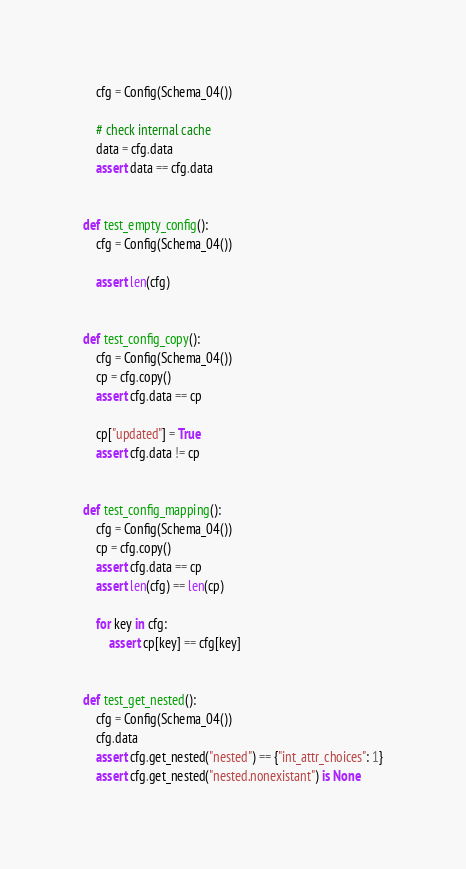<code> <loc_0><loc_0><loc_500><loc_500><_Python_>    cfg = Config(Schema_04())

    # check internal cache
    data = cfg.data
    assert data == cfg.data


def test_empty_config():
    cfg = Config(Schema_04())

    assert len(cfg)


def test_config_copy():
    cfg = Config(Schema_04())
    cp = cfg.copy()
    assert cfg.data == cp

    cp["updated"] = True
    assert cfg.data != cp


def test_config_mapping():
    cfg = Config(Schema_04())
    cp = cfg.copy()
    assert cfg.data == cp
    assert len(cfg) == len(cp)

    for key in cfg:
        assert cp[key] == cfg[key]


def test_get_nested():
    cfg = Config(Schema_04())
    cfg.data
    assert cfg.get_nested("nested") == {"int_attr_choices": 1}
    assert cfg.get_nested("nested.nonexistant") is None
</code> 